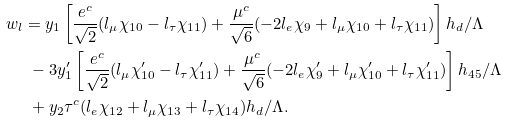Convert formula to latex. <formula><loc_0><loc_0><loc_500><loc_500>w _ { l } & = y _ { 1 } \left [ \frac { e ^ { c } } { \sqrt { 2 } } ( l _ { \mu } \chi _ { 1 0 } - l _ { \tau } \chi _ { 1 1 } ) + \frac { \mu ^ { c } } { \sqrt { 6 } } ( - 2 l _ { e } \chi _ { 9 } + l _ { \mu } \chi _ { 1 0 } + l _ { \tau } \chi _ { 1 1 } ) \right ] h _ { d } / \Lambda \\ & \ - 3 y _ { 1 } ^ { \prime } \left [ \frac { e ^ { c } } { \sqrt { 2 } } ( l _ { \mu } \chi _ { 1 0 } ^ { \prime } - l _ { \tau } \chi _ { 1 1 } ^ { \prime } ) + \frac { \mu ^ { c } } { \sqrt { 6 } } ( - 2 l _ { e } \chi _ { 9 } ^ { \prime } + l _ { \mu } \chi _ { 1 0 } ^ { \prime } + l _ { \tau } \chi _ { 1 1 } ^ { \prime } ) \right ] h _ { 4 5 } / \Lambda \\ & \ + y _ { 2 } \tau ^ { c } ( l _ { e } \chi _ { 1 2 } + l _ { \mu } \chi _ { 1 3 } + l _ { \tau } \chi _ { 1 4 } ) h _ { d } / \Lambda .</formula> 